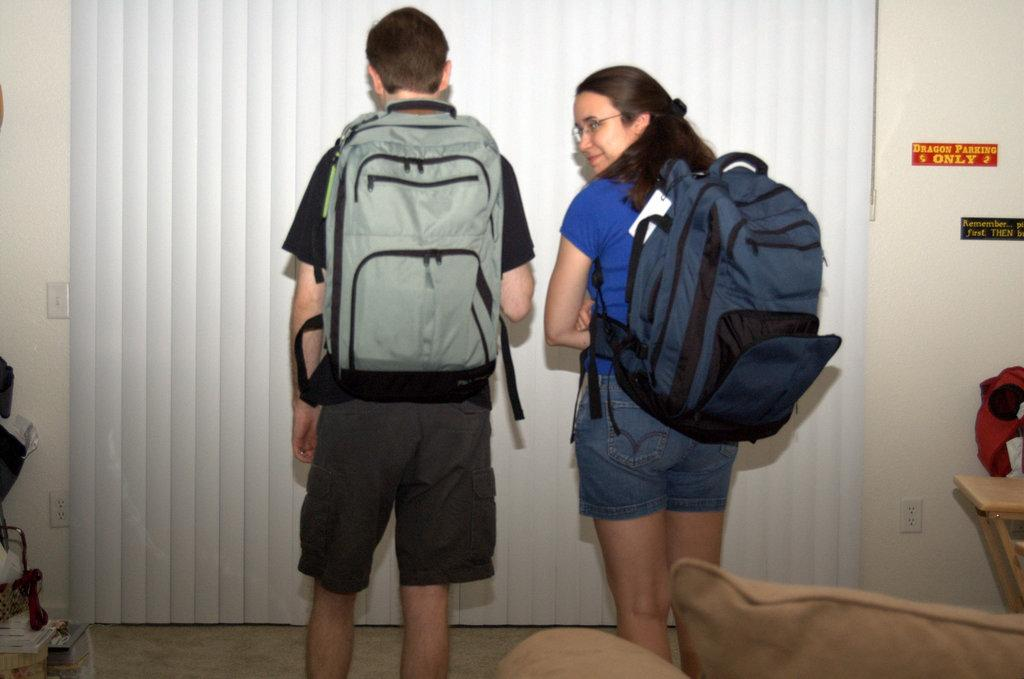How many people are in the image? There are two persons in the image. What are the persons doing in the image? The persons are standing on the floor. What are the persons carrying in the image? The persons are carrying backpacks. What can be seen on the wall in the image? There is a curtain in the image. What is the background of the image? There is a wall in the image. What type of silk fabric is draped over the letters in the image? There are no letters or silk fabric present in the image. 